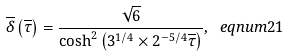<formula> <loc_0><loc_0><loc_500><loc_500>\overline { \delta } \left ( \overline { \tau } \right ) = \frac { \sqrt { 6 } } { \cosh ^ { 2 } \left ( 3 ^ { 1 / 4 } \times 2 ^ { - 5 / 4 } \overline { \tau } \right ) } , \ e q n u m { 2 1 }</formula> 